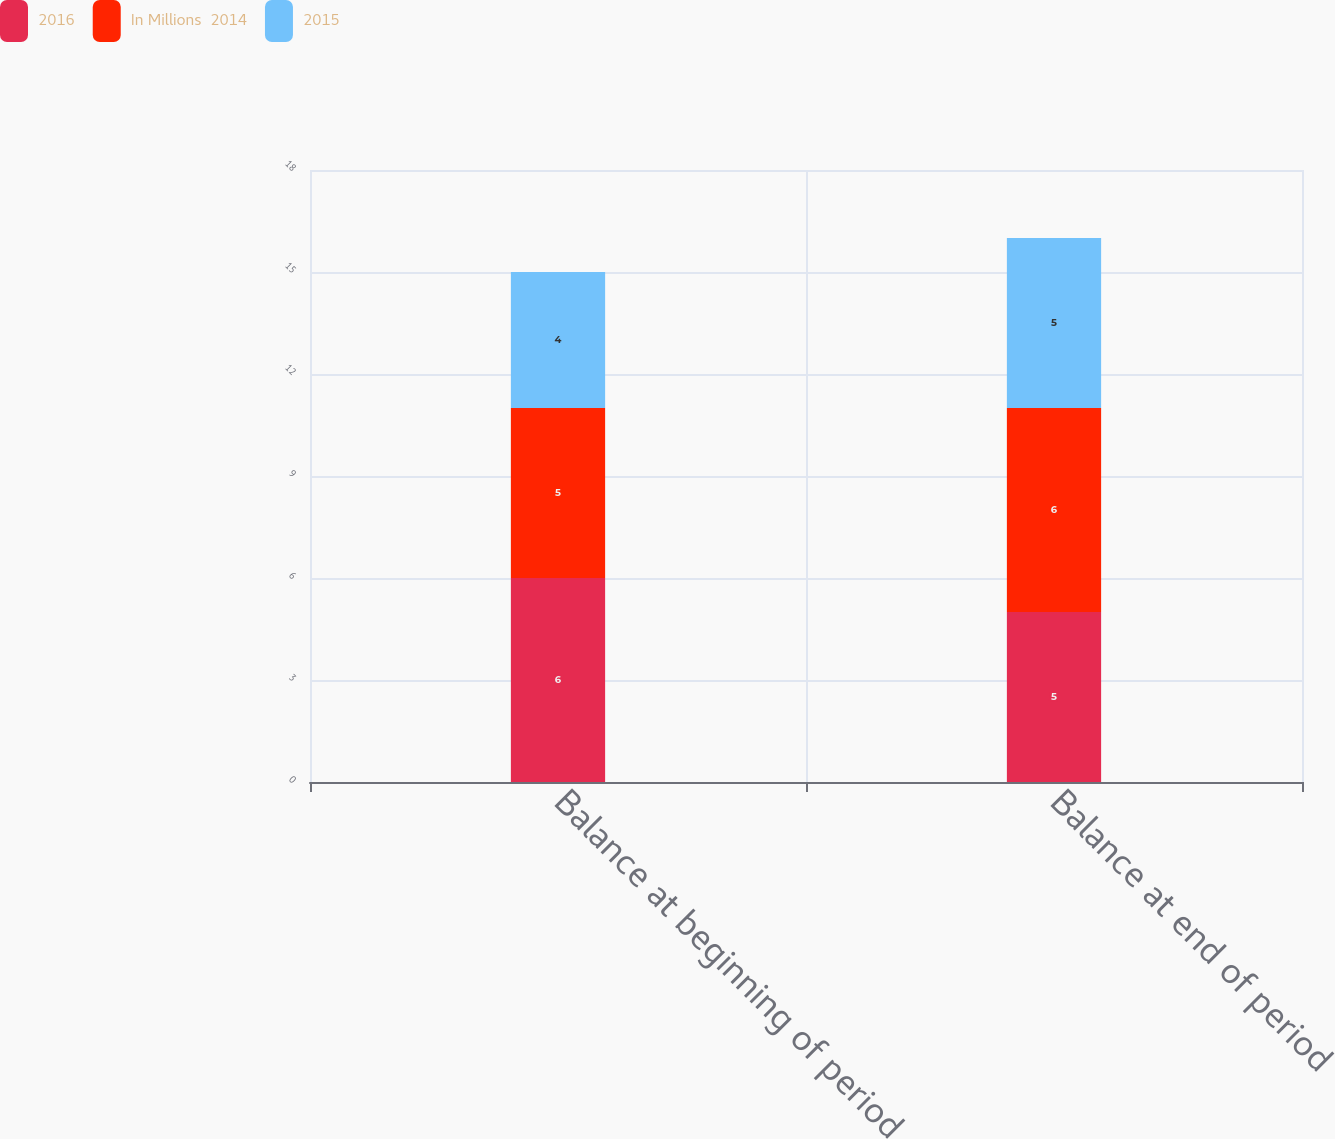<chart> <loc_0><loc_0><loc_500><loc_500><stacked_bar_chart><ecel><fcel>Balance at beginning of period<fcel>Balance at end of period<nl><fcel>2016<fcel>6<fcel>5<nl><fcel>In Millions  2014<fcel>5<fcel>6<nl><fcel>2015<fcel>4<fcel>5<nl></chart> 